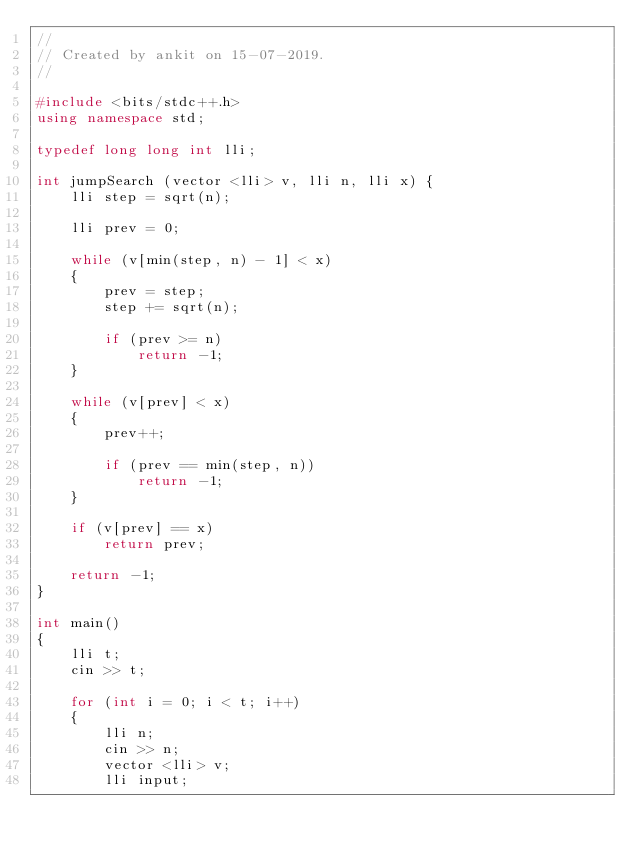<code> <loc_0><loc_0><loc_500><loc_500><_C++_>//
// Created by ankit on 15-07-2019.
//

#include <bits/stdc++.h>
using namespace std;

typedef long long int lli;

int jumpSearch (vector <lli> v, lli n, lli x) {
    lli step = sqrt(n);

    lli prev = 0;

    while (v[min(step, n) - 1] < x)
    {
        prev = step;
        step += sqrt(n);

        if (prev >= n)
            return -1;
    }

    while (v[prev] < x)
    {
        prev++;

        if (prev == min(step, n))
            return -1;
    }

    if (v[prev] == x)
        return prev;

    return -1;
}

int main()
{
    lli t;
    cin >> t;

    for (int i = 0; i < t; i++)
    {
        lli n;
        cin >> n;
        vector <lli> v;
        lli input;
</code> 